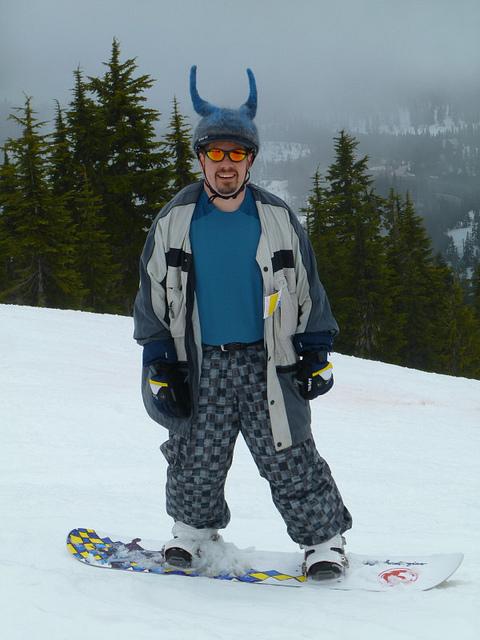Is there a ramp in the pic?
Write a very short answer. No. What sport is being demonstrated here?
Give a very brief answer. Snowboarding. Is he dressed for the weather?
Concise answer only. Yes. Is the man skiing?
Be succinct. No. What is he doing?
Quick response, please. Snowboarding. What is in the people's hands?
Give a very brief answer. Gloves. Do the trees in the background have any snow on them?
Quick response, please. No. What is she doing?
Write a very short answer. Snowboarding. Would eyeglasses touch the man's beard?
Be succinct. No. Is it cold?
Concise answer only. Yes. What color is the man's shirt?
Short answer required. Blue. What is the pattern of his pants?
Write a very short answer. Checkered. What is the gender of this person in ski regalia?
Keep it brief. Male. 